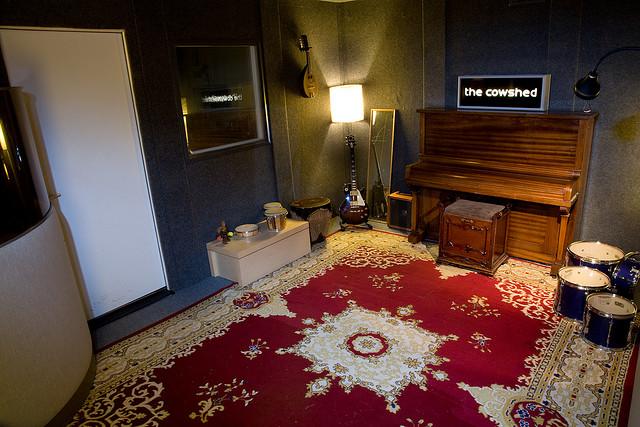What does the sign say?
Keep it brief. The cowshed. Is the floor made of tiles?
Quick response, please. No. Where is the piano?
Quick response, please. Right. 